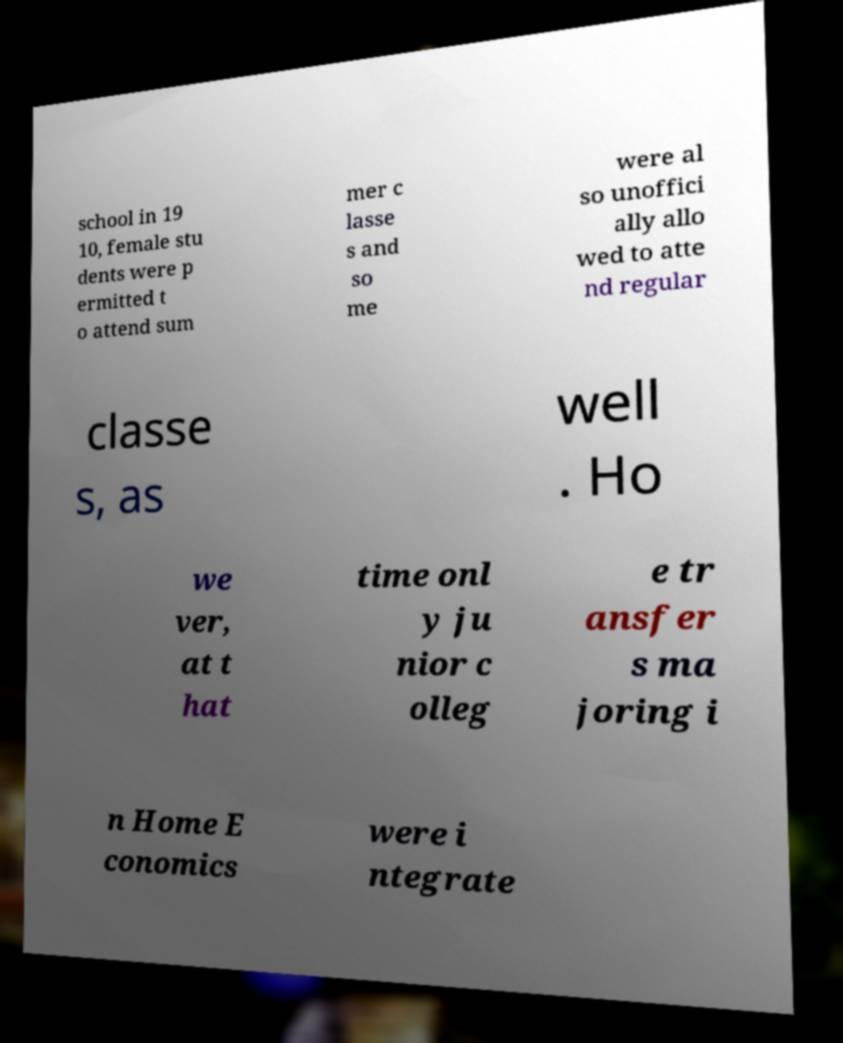Please read and relay the text visible in this image. What does it say? school in 19 10, female stu dents were p ermitted t o attend sum mer c lasse s and so me were al so unoffici ally allo wed to atte nd regular classe s, as well . Ho we ver, at t hat time onl y ju nior c olleg e tr ansfer s ma joring i n Home E conomics were i ntegrate 